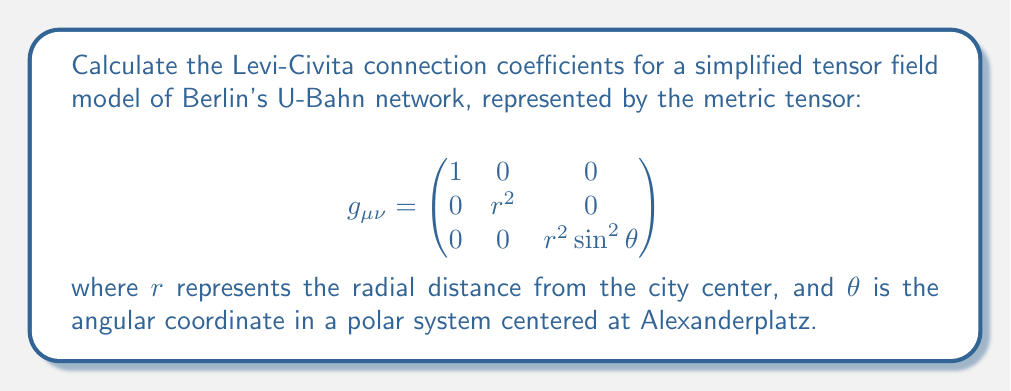Provide a solution to this math problem. To calculate the Levi-Civita connection coefficients, we'll follow these steps:

1) The Levi-Civita connection coefficients are given by:

   $$\Gamma^\lambda_{\mu\nu} = \frac{1}{2}g^{\lambda\sigma}(\partial_\mu g_{\nu\sigma} + \partial_\nu g_{\mu\sigma} - \partial_\sigma g_{\mu\nu})$$

2) First, we need to find the inverse metric tensor $g^{\mu\nu}$:

   $$g^{\mu\nu} = \begin{pmatrix}
   1 & 0 & 0 \\
   0 & \frac{1}{r^2} & 0 \\
   0 & 0 & \frac{1}{r^2\sin^2\theta}
   \end{pmatrix}$$

3) Now, we calculate the partial derivatives of the metric tensor:

   $\partial_r g_{\theta\theta} = 2r$
   $\partial_r g_{\phi\phi} = 2r\sin^2\theta$
   $\partial_\theta g_{\phi\phi} = 2r^2\sin\theta\cos\theta$

   All other partial derivatives are zero.

4) We can now calculate the non-zero connection coefficients:

   $\Gamma^r_{\theta\theta} = -r$
   $\Gamma^r_{\phi\phi} = -r\sin^2\theta$
   $\Gamma^\theta_{r\theta} = \Gamma^\theta_{\theta r} = \frac{1}{r}$
   $\Gamma^\theta_{\phi\phi} = -\sin\theta\cos\theta$
   $\Gamma^\phi_{r\phi} = \Gamma^\phi_{\phi r} = \frac{1}{r}$
   $\Gamma^\phi_{\theta\phi} = \Gamma^\phi_{\phi\theta} = \cot\theta$

5) All other connection coefficients are zero.

This simplified model represents the U-Bahn network as a curved space, where the curvature reflects the density and complexity of the transportation system as one moves away from the city center.
Answer: $\Gamma^r_{\theta\theta} = -r$, $\Gamma^r_{\phi\phi} = -r\sin^2\theta$, $\Gamma^\theta_{r\theta} = \Gamma^\theta_{\theta r} = \frac{1}{r}$, $\Gamma^\theta_{\phi\phi} = -\sin\theta\cos\theta$, $\Gamma^\phi_{r\phi} = \Gamma^\phi_{\phi r} = \frac{1}{r}$, $\Gamma^\phi_{\theta\phi} = \Gamma^\phi_{\phi\theta} = \cot\theta$, all others zero. 